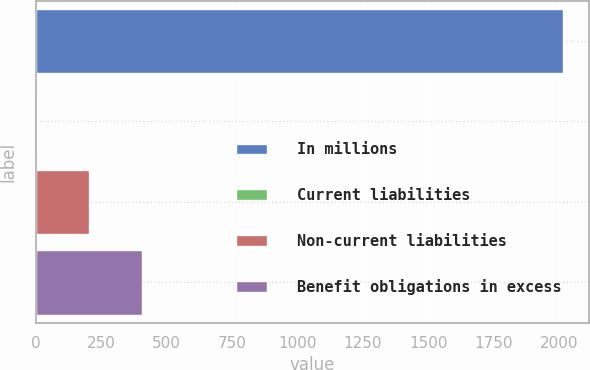Convert chart. <chart><loc_0><loc_0><loc_500><loc_500><bar_chart><fcel>In millions<fcel>Current liabilities<fcel>Non-current liabilities<fcel>Benefit obligations in excess<nl><fcel>2015<fcel>4.1<fcel>205.19<fcel>406.28<nl></chart> 